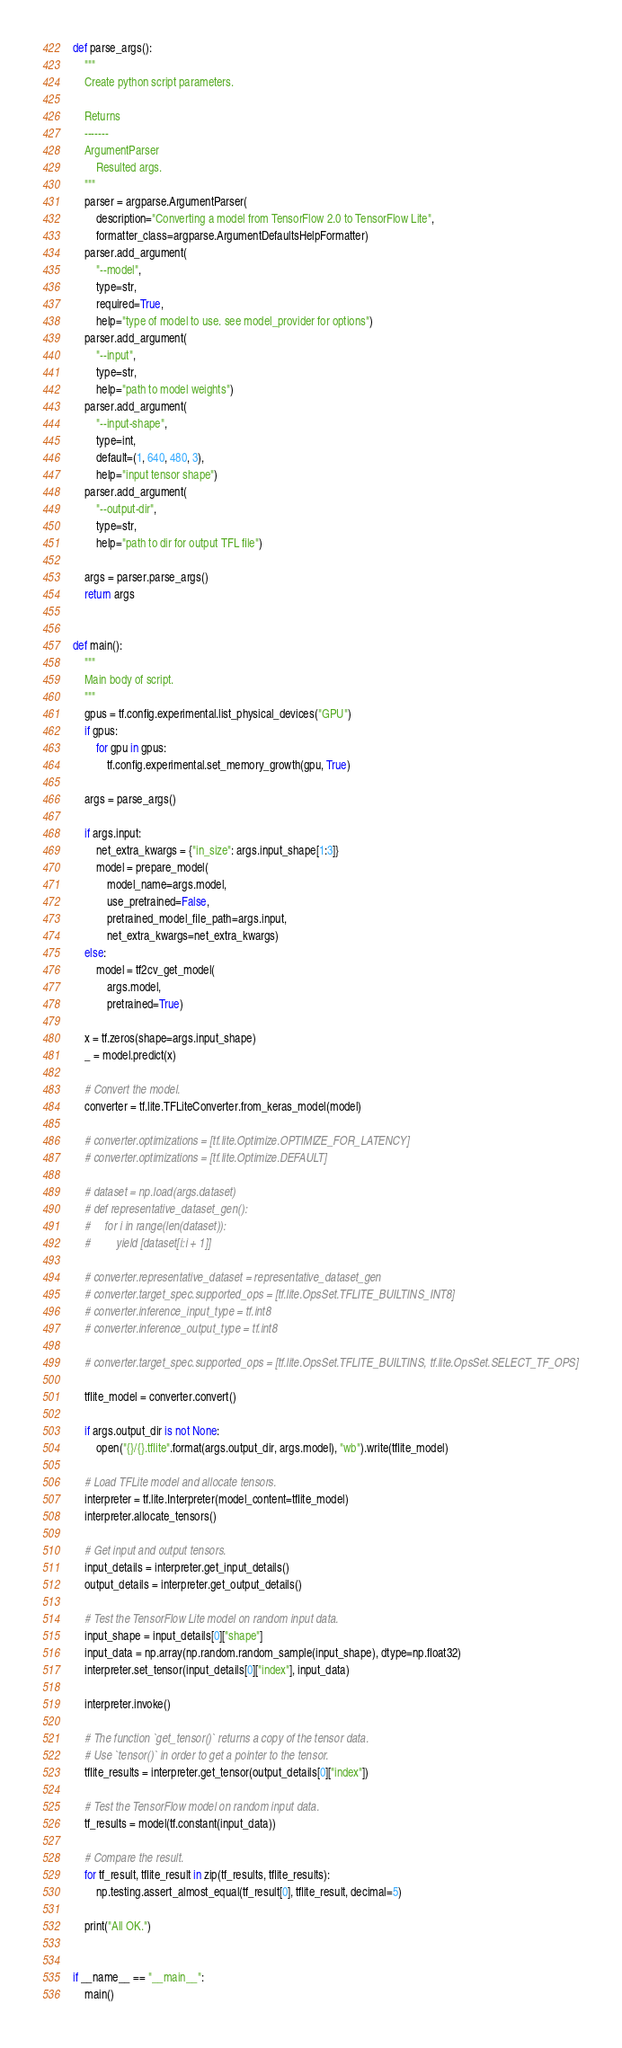<code> <loc_0><loc_0><loc_500><loc_500><_Python_>

def parse_args():
    """
    Create python script parameters.

    Returns
    -------
    ArgumentParser
        Resulted args.
    """
    parser = argparse.ArgumentParser(
        description="Converting a model from TensorFlow 2.0 to TensorFlow Lite",
        formatter_class=argparse.ArgumentDefaultsHelpFormatter)
    parser.add_argument(
        "--model",
        type=str,
        required=True,
        help="type of model to use. see model_provider for options")
    parser.add_argument(
        "--input",
        type=str,
        help="path to model weights")
    parser.add_argument(
        "--input-shape",
        type=int,
        default=(1, 640, 480, 3),
        help="input tensor shape")
    parser.add_argument(
        "--output-dir",
        type=str,
        help="path to dir for output TFL file")

    args = parser.parse_args()
    return args


def main():
    """
    Main body of script.
    """
    gpus = tf.config.experimental.list_physical_devices("GPU")
    if gpus:
        for gpu in gpus:
            tf.config.experimental.set_memory_growth(gpu, True)

    args = parse_args()

    if args.input:
        net_extra_kwargs = {"in_size": args.input_shape[1:3]}
        model = prepare_model(
            model_name=args.model,
            use_pretrained=False,
            pretrained_model_file_path=args.input,
            net_extra_kwargs=net_extra_kwargs)
    else:
        model = tf2cv_get_model(
            args.model,
            pretrained=True)

    x = tf.zeros(shape=args.input_shape)
    _ = model.predict(x)

    # Convert the model.
    converter = tf.lite.TFLiteConverter.from_keras_model(model)

    # converter.optimizations = [tf.lite.Optimize.OPTIMIZE_FOR_LATENCY]
    # converter.optimizations = [tf.lite.Optimize.DEFAULT]

    # dataset = np.load(args.dataset)
    # def representative_dataset_gen():
    #     for i in range(len(dataset)):
    #         yield [dataset[i:i + 1]]

    # converter.representative_dataset = representative_dataset_gen
    # converter.target_spec.supported_ops = [tf.lite.OpsSet.TFLITE_BUILTINS_INT8]
    # converter.inference_input_type = tf.int8
    # converter.inference_output_type = tf.int8

    # converter.target_spec.supported_ops = [tf.lite.OpsSet.TFLITE_BUILTINS, tf.lite.OpsSet.SELECT_TF_OPS]

    tflite_model = converter.convert()

    if args.output_dir is not None:
        open("{}/{}.tflite".format(args.output_dir, args.model), "wb").write(tflite_model)

    # Load TFLite model and allocate tensors.
    interpreter = tf.lite.Interpreter(model_content=tflite_model)
    interpreter.allocate_tensors()

    # Get input and output tensors.
    input_details = interpreter.get_input_details()
    output_details = interpreter.get_output_details()

    # Test the TensorFlow Lite model on random input data.
    input_shape = input_details[0]["shape"]
    input_data = np.array(np.random.random_sample(input_shape), dtype=np.float32)
    interpreter.set_tensor(input_details[0]["index"], input_data)

    interpreter.invoke()

    # The function `get_tensor()` returns a copy of the tensor data.
    # Use `tensor()` in order to get a pointer to the tensor.
    tflite_results = interpreter.get_tensor(output_details[0]["index"])

    # Test the TensorFlow model on random input data.
    tf_results = model(tf.constant(input_data))

    # Compare the result.
    for tf_result, tflite_result in zip(tf_results, tflite_results):
        np.testing.assert_almost_equal(tf_result[0], tflite_result, decimal=5)

    print("All OK.")


if __name__ == "__main__":
    main()
</code> 